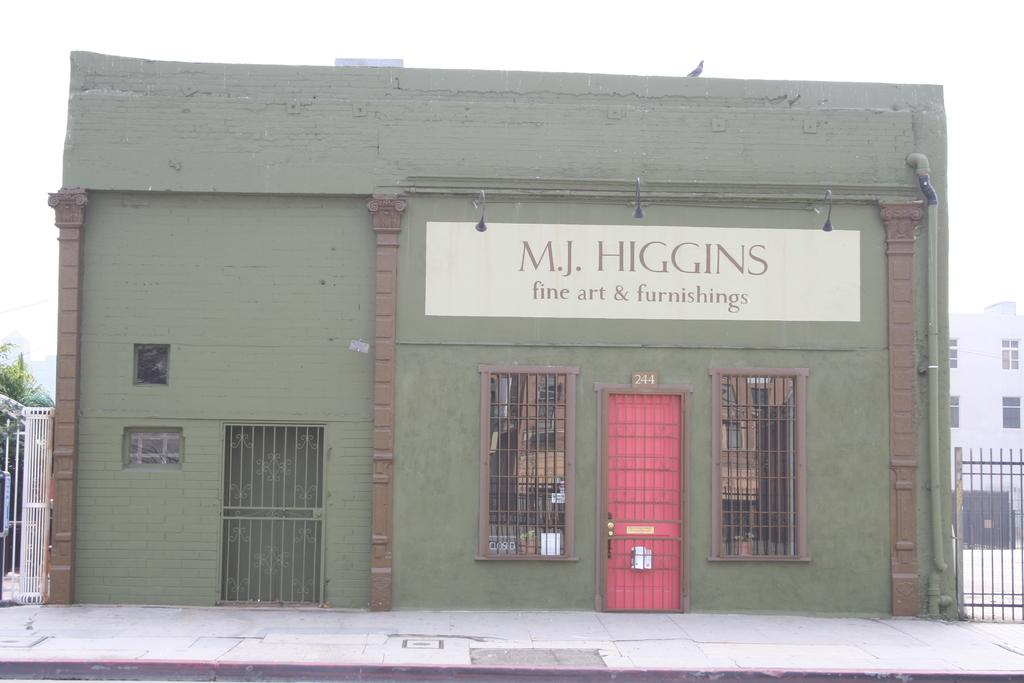What type of path is visible in the image? There is a footpath in the image. Where is the footpath located in relation to the building? The footpath is in front of a building. What is present on both sides of the footpath? There is fencing on the left side and the right side of the image. What can be seen in the background of the image? The sky is visible in the background of the image. What type of plantation can be seen in the image? There is no plantation present in the image; it features a footpath, a building, fencing, and the sky. 